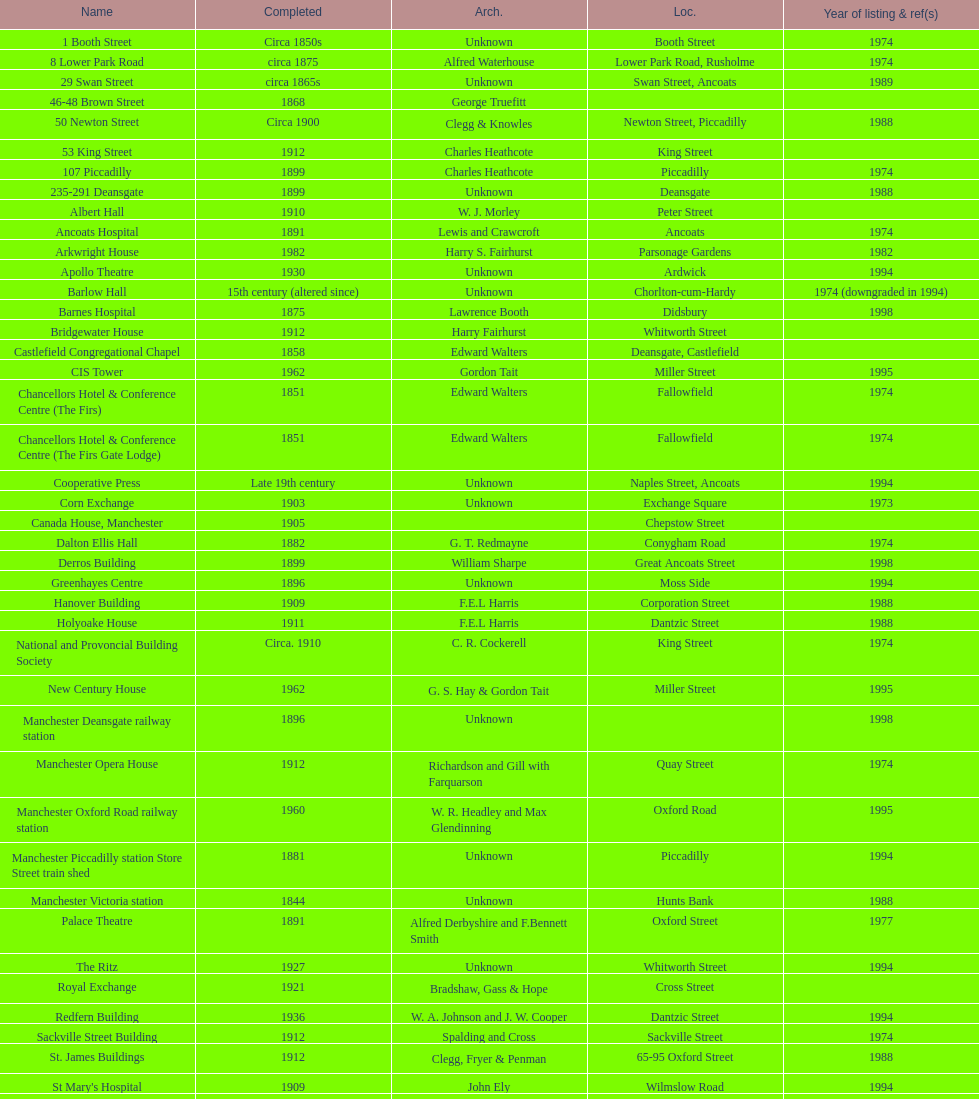How many buildings had alfred waterhouse as their architect? 3. 